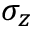Convert formula to latex. <formula><loc_0><loc_0><loc_500><loc_500>\sigma _ { z }</formula> 